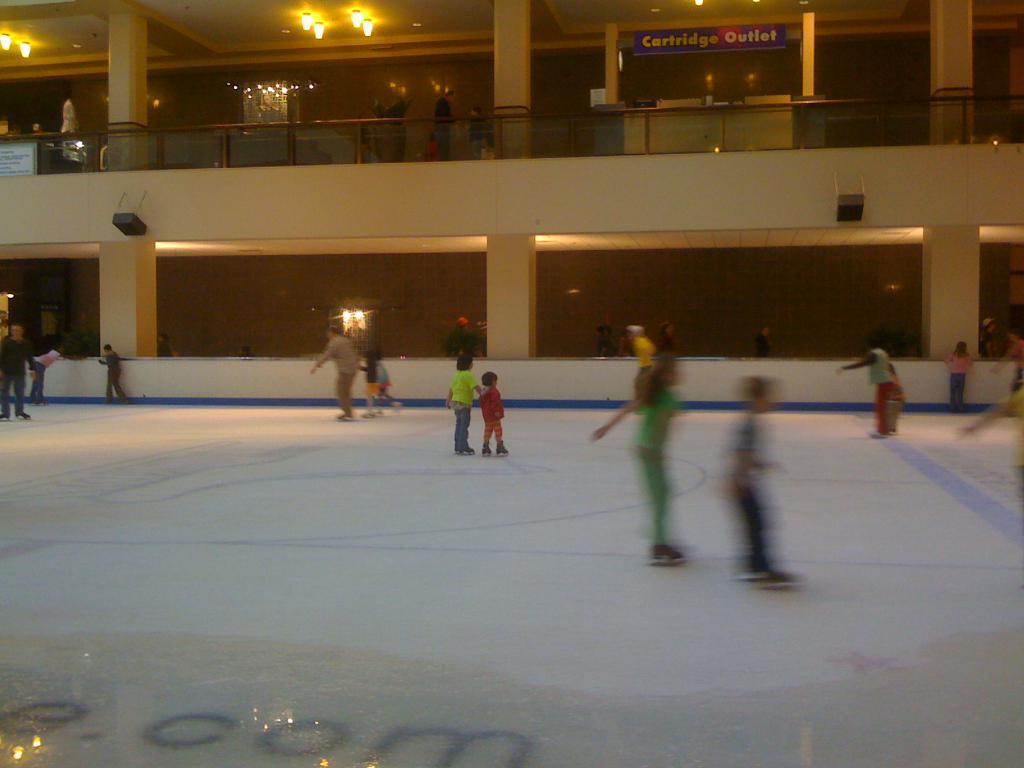What are the people in the image doing? The people in the center of the image are skating. What can be seen in the background of the image? In the background of the image, there is a wall, a fence, a photo frame, lights, pillars, banners, speakers, and other objects. Can you describe the setting of the image? The image appears to be set in an area with a skating rink, surrounded by various structures and decorations. What type of lunch is being served in the image? There is no lunch present in the image; it features people skating and various background elements. Are there any astronauts visible in the image? No, there are no astronauts or any references to space in the image. 